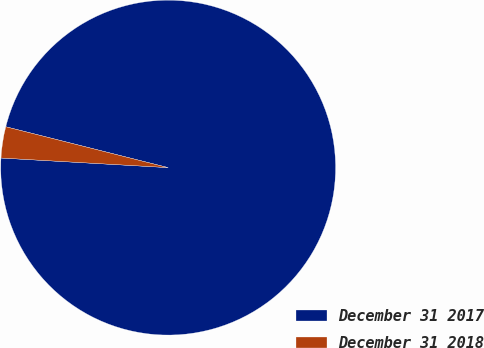Convert chart to OTSL. <chart><loc_0><loc_0><loc_500><loc_500><pie_chart><fcel>December 31 2017<fcel>December 31 2018<nl><fcel>96.99%<fcel>3.01%<nl></chart> 